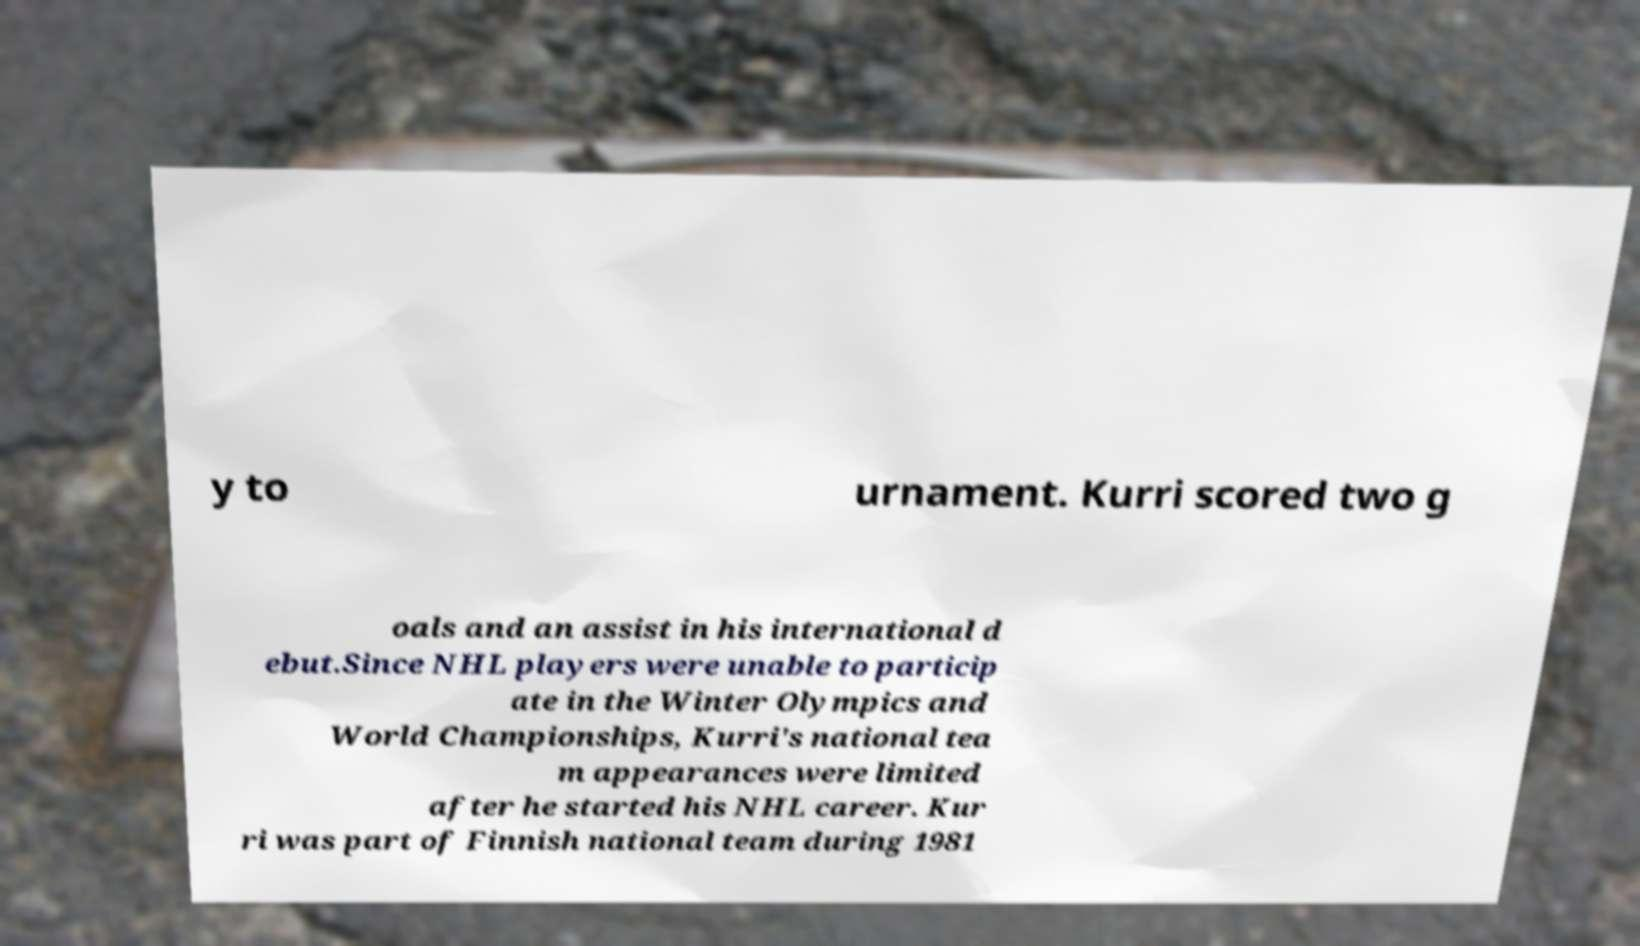Please read and relay the text visible in this image. What does it say? y to urnament. Kurri scored two g oals and an assist in his international d ebut.Since NHL players were unable to particip ate in the Winter Olympics and World Championships, Kurri's national tea m appearances were limited after he started his NHL career. Kur ri was part of Finnish national team during 1981 